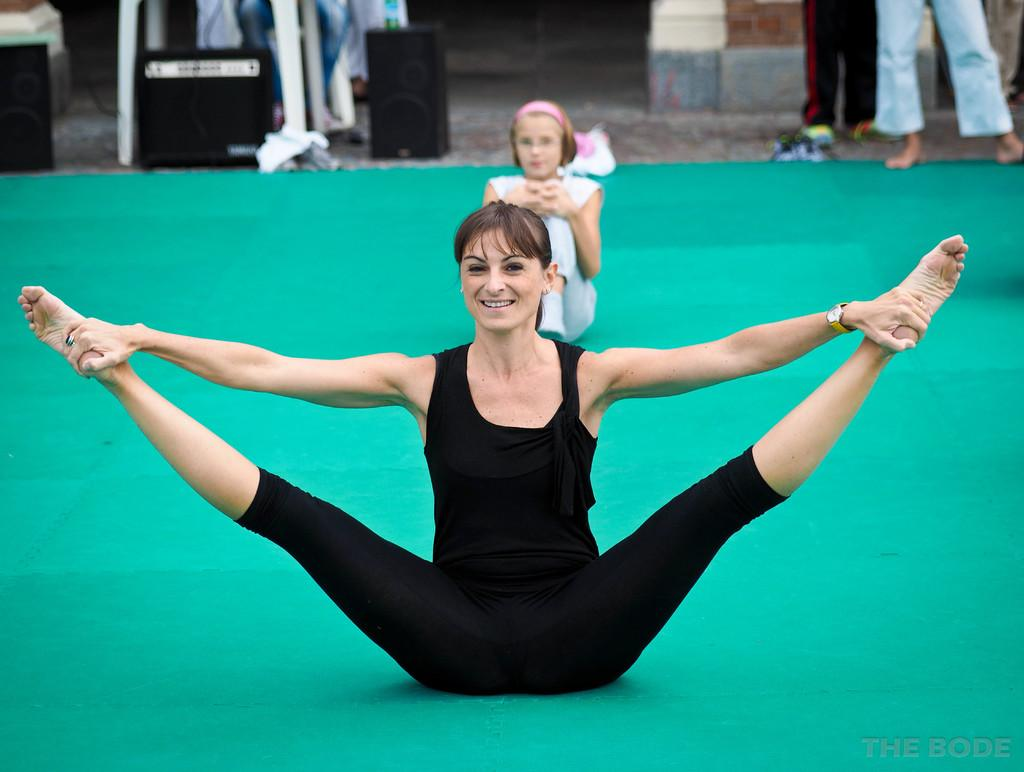What is the woman in the foreground of the image doing? The woman is doing aerobics in the foreground of the image. What is the woman standing on while doing aerobics? The woman is on a green mat. What is the girl in the image doing? The girl is sitting in the center of the image. What can be seen in the top part of the image? There are people, a stand, a floor, and other objects visible in the top part of the image. What type of vest is the woman wearing to help her with her aerobics in the image? There is no mention of a vest in the image, and the woman's clothing is not described. Additionally, the image does not provide any information about the woman needing help with her aerobics. 